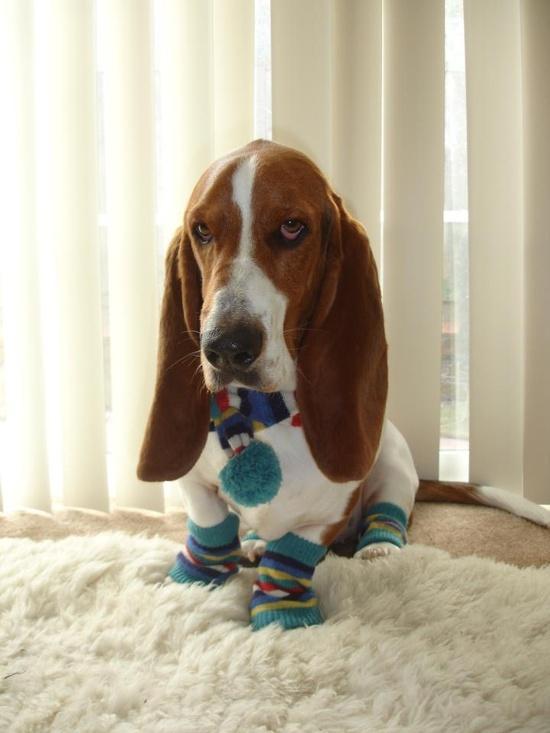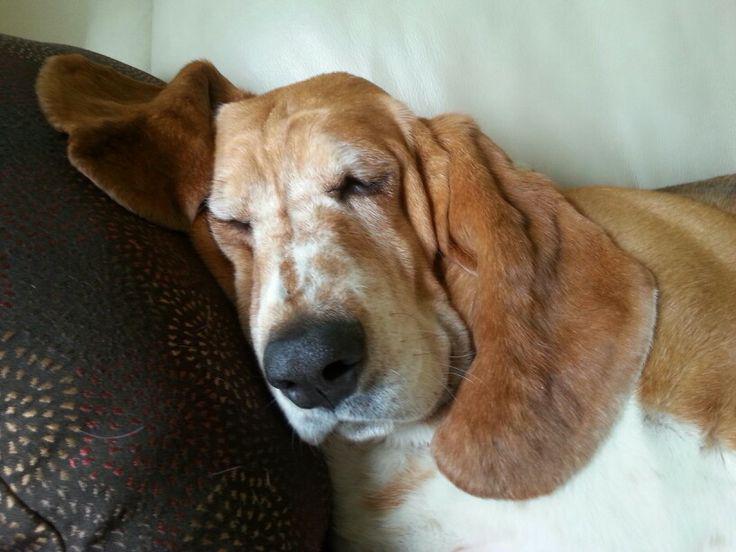The first image is the image on the left, the second image is the image on the right. Given the left and right images, does the statement "One image shows a forward-facing hound posed indoors wearing some type of outfit that includes a scarf." hold true? Answer yes or no. Yes. The first image is the image on the left, the second image is the image on the right. For the images displayed, is the sentence "One of the dogs is wearing an item of clothing." factually correct? Answer yes or no. Yes. 